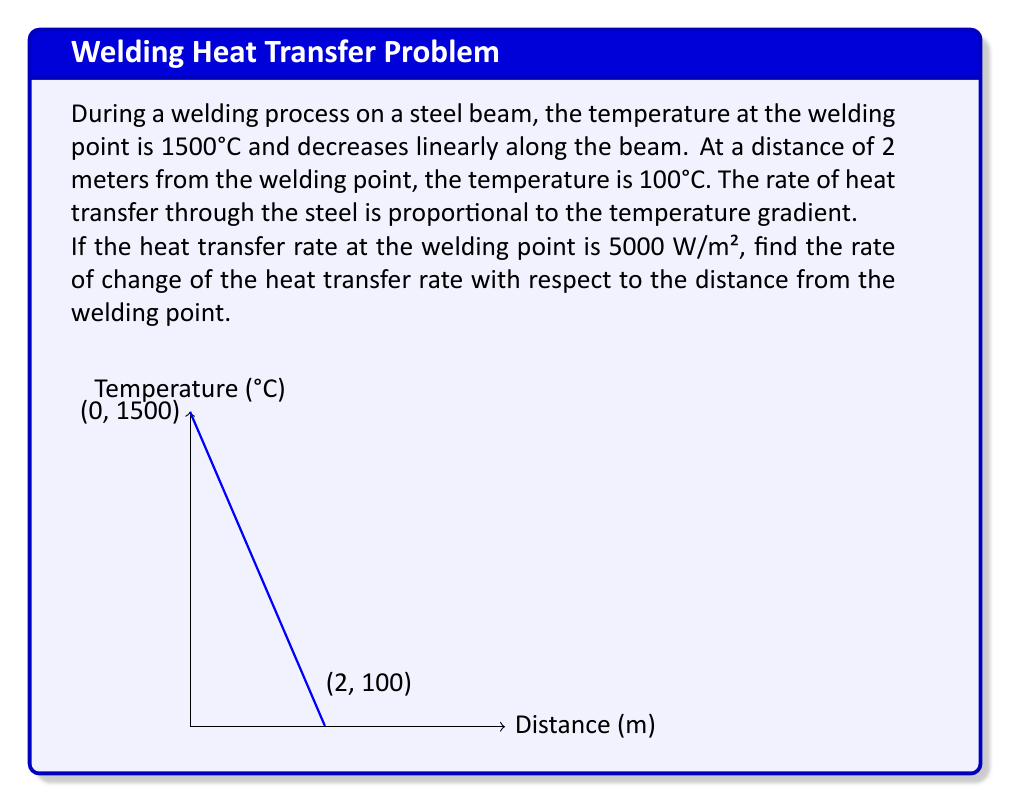Can you solve this math problem? Let's approach this step-by-step:

1) First, we need to find the temperature gradient along the beam. We can do this using the linear temperature distribution:

   Temperature change = 1500°C - 100°C = 1400°C
   Distance = 2 m
   Temperature gradient = $\frac{1400°C}{2 m} = 700°C/m$

2) The temperature $T$ as a function of distance $x$ from the welding point is:
   
   $T(x) = 1500 - 700x$

3) The heat transfer rate $q$ is proportional to the temperature gradient:
   
   $q = -k\frac{dT}{dx}$

   where $k$ is the thermal conductivity of steel.

4) We know that at $x=0$ (the welding point), $q = 5000 W/m²$. So:

   $5000 = -k(-700)$
   $k = \frac{5000}{700} = \frac{50}{7} W/(m·°C)$

5) Now we can express $q$ as a function of $x$:

   $q(x) = -\frac{50}{7}(-700) = 5000 W/m²$

6) To find the rate of change of the heat transfer rate with respect to distance, we need to differentiate $q$ with respect to $x$:

   $\frac{dq}{dx} = \frac{d}{dx}(5000) = 0$
Answer: $0 W/m³$ 